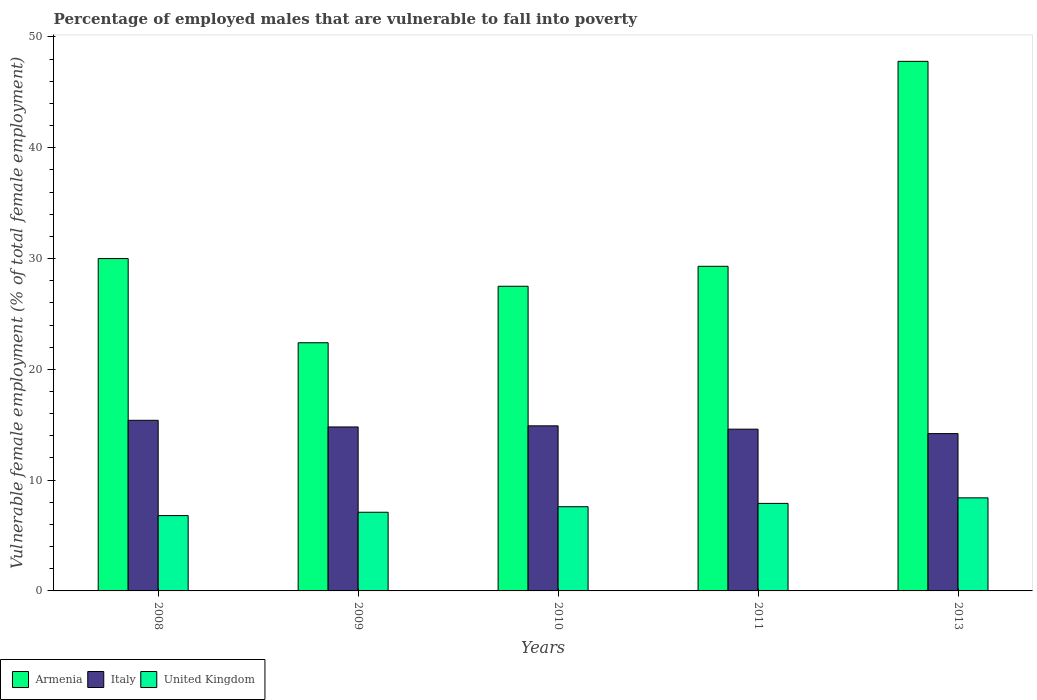How many groups of bars are there?
Your answer should be very brief. 5. Are the number of bars on each tick of the X-axis equal?
Your response must be concise. Yes. What is the percentage of employed males who are vulnerable to fall into poverty in United Kingdom in 2010?
Offer a very short reply. 7.6. Across all years, what is the maximum percentage of employed males who are vulnerable to fall into poverty in United Kingdom?
Your answer should be very brief. 8.4. Across all years, what is the minimum percentage of employed males who are vulnerable to fall into poverty in Armenia?
Offer a very short reply. 22.4. In which year was the percentage of employed males who are vulnerable to fall into poverty in Armenia minimum?
Your response must be concise. 2009. What is the total percentage of employed males who are vulnerable to fall into poverty in Armenia in the graph?
Provide a short and direct response. 157. What is the difference between the percentage of employed males who are vulnerable to fall into poverty in United Kingdom in 2010 and that in 2013?
Your answer should be very brief. -0.8. What is the difference between the percentage of employed males who are vulnerable to fall into poverty in Armenia in 2011 and the percentage of employed males who are vulnerable to fall into poverty in United Kingdom in 2013?
Your response must be concise. 20.9. What is the average percentage of employed males who are vulnerable to fall into poverty in Italy per year?
Offer a very short reply. 14.78. In the year 2009, what is the difference between the percentage of employed males who are vulnerable to fall into poverty in Armenia and percentage of employed males who are vulnerable to fall into poverty in Italy?
Offer a very short reply. 7.6. What is the ratio of the percentage of employed males who are vulnerable to fall into poverty in Italy in 2008 to that in 2011?
Give a very brief answer. 1.05. Is the percentage of employed males who are vulnerable to fall into poverty in Armenia in 2008 less than that in 2011?
Your response must be concise. No. Is the difference between the percentage of employed males who are vulnerable to fall into poverty in Armenia in 2009 and 2011 greater than the difference between the percentage of employed males who are vulnerable to fall into poverty in Italy in 2009 and 2011?
Offer a terse response. No. What is the difference between the highest and the second highest percentage of employed males who are vulnerable to fall into poverty in United Kingdom?
Ensure brevity in your answer.  0.5. What is the difference between the highest and the lowest percentage of employed males who are vulnerable to fall into poverty in Italy?
Provide a succinct answer. 1.2. Is the sum of the percentage of employed males who are vulnerable to fall into poverty in Armenia in 2010 and 2011 greater than the maximum percentage of employed males who are vulnerable to fall into poverty in Italy across all years?
Your answer should be very brief. Yes. What does the 1st bar from the left in 2011 represents?
Your answer should be very brief. Armenia. What does the 1st bar from the right in 2011 represents?
Offer a very short reply. United Kingdom. Is it the case that in every year, the sum of the percentage of employed males who are vulnerable to fall into poverty in United Kingdom and percentage of employed males who are vulnerable to fall into poverty in Italy is greater than the percentage of employed males who are vulnerable to fall into poverty in Armenia?
Keep it short and to the point. No. How many years are there in the graph?
Keep it short and to the point. 5. What is the difference between two consecutive major ticks on the Y-axis?
Provide a succinct answer. 10. Are the values on the major ticks of Y-axis written in scientific E-notation?
Keep it short and to the point. No. What is the title of the graph?
Provide a succinct answer. Percentage of employed males that are vulnerable to fall into poverty. What is the label or title of the Y-axis?
Give a very brief answer. Vulnerable female employment (% of total female employment). What is the Vulnerable female employment (% of total female employment) of Italy in 2008?
Give a very brief answer. 15.4. What is the Vulnerable female employment (% of total female employment) of United Kingdom in 2008?
Your response must be concise. 6.8. What is the Vulnerable female employment (% of total female employment) in Armenia in 2009?
Your answer should be compact. 22.4. What is the Vulnerable female employment (% of total female employment) in Italy in 2009?
Provide a succinct answer. 14.8. What is the Vulnerable female employment (% of total female employment) in United Kingdom in 2009?
Provide a short and direct response. 7.1. What is the Vulnerable female employment (% of total female employment) of Italy in 2010?
Ensure brevity in your answer.  14.9. What is the Vulnerable female employment (% of total female employment) of United Kingdom in 2010?
Provide a short and direct response. 7.6. What is the Vulnerable female employment (% of total female employment) of Armenia in 2011?
Your answer should be very brief. 29.3. What is the Vulnerable female employment (% of total female employment) in Italy in 2011?
Provide a succinct answer. 14.6. What is the Vulnerable female employment (% of total female employment) in United Kingdom in 2011?
Offer a terse response. 7.9. What is the Vulnerable female employment (% of total female employment) of Armenia in 2013?
Offer a very short reply. 47.8. What is the Vulnerable female employment (% of total female employment) in Italy in 2013?
Provide a short and direct response. 14.2. What is the Vulnerable female employment (% of total female employment) of United Kingdom in 2013?
Your response must be concise. 8.4. Across all years, what is the maximum Vulnerable female employment (% of total female employment) in Armenia?
Provide a short and direct response. 47.8. Across all years, what is the maximum Vulnerable female employment (% of total female employment) of Italy?
Your response must be concise. 15.4. Across all years, what is the maximum Vulnerable female employment (% of total female employment) of United Kingdom?
Provide a short and direct response. 8.4. Across all years, what is the minimum Vulnerable female employment (% of total female employment) of Armenia?
Provide a short and direct response. 22.4. Across all years, what is the minimum Vulnerable female employment (% of total female employment) in Italy?
Provide a succinct answer. 14.2. Across all years, what is the minimum Vulnerable female employment (% of total female employment) of United Kingdom?
Keep it short and to the point. 6.8. What is the total Vulnerable female employment (% of total female employment) of Armenia in the graph?
Your answer should be compact. 157. What is the total Vulnerable female employment (% of total female employment) of Italy in the graph?
Offer a very short reply. 73.9. What is the total Vulnerable female employment (% of total female employment) in United Kingdom in the graph?
Keep it short and to the point. 37.8. What is the difference between the Vulnerable female employment (% of total female employment) of Armenia in 2008 and that in 2009?
Offer a terse response. 7.6. What is the difference between the Vulnerable female employment (% of total female employment) in United Kingdom in 2008 and that in 2009?
Your answer should be compact. -0.3. What is the difference between the Vulnerable female employment (% of total female employment) in Italy in 2008 and that in 2011?
Ensure brevity in your answer.  0.8. What is the difference between the Vulnerable female employment (% of total female employment) of United Kingdom in 2008 and that in 2011?
Your response must be concise. -1.1. What is the difference between the Vulnerable female employment (% of total female employment) of Armenia in 2008 and that in 2013?
Provide a succinct answer. -17.8. What is the difference between the Vulnerable female employment (% of total female employment) of Italy in 2008 and that in 2013?
Your answer should be compact. 1.2. What is the difference between the Vulnerable female employment (% of total female employment) in United Kingdom in 2008 and that in 2013?
Keep it short and to the point. -1.6. What is the difference between the Vulnerable female employment (% of total female employment) in Armenia in 2009 and that in 2010?
Offer a very short reply. -5.1. What is the difference between the Vulnerable female employment (% of total female employment) in Italy in 2009 and that in 2010?
Offer a terse response. -0.1. What is the difference between the Vulnerable female employment (% of total female employment) of Armenia in 2009 and that in 2011?
Provide a succinct answer. -6.9. What is the difference between the Vulnerable female employment (% of total female employment) of United Kingdom in 2009 and that in 2011?
Ensure brevity in your answer.  -0.8. What is the difference between the Vulnerable female employment (% of total female employment) of Armenia in 2009 and that in 2013?
Provide a short and direct response. -25.4. What is the difference between the Vulnerable female employment (% of total female employment) of Italy in 2009 and that in 2013?
Offer a very short reply. 0.6. What is the difference between the Vulnerable female employment (% of total female employment) in United Kingdom in 2009 and that in 2013?
Provide a short and direct response. -1.3. What is the difference between the Vulnerable female employment (% of total female employment) of United Kingdom in 2010 and that in 2011?
Give a very brief answer. -0.3. What is the difference between the Vulnerable female employment (% of total female employment) in Armenia in 2010 and that in 2013?
Give a very brief answer. -20.3. What is the difference between the Vulnerable female employment (% of total female employment) of Italy in 2010 and that in 2013?
Keep it short and to the point. 0.7. What is the difference between the Vulnerable female employment (% of total female employment) in United Kingdom in 2010 and that in 2013?
Ensure brevity in your answer.  -0.8. What is the difference between the Vulnerable female employment (% of total female employment) in Armenia in 2011 and that in 2013?
Offer a terse response. -18.5. What is the difference between the Vulnerable female employment (% of total female employment) in Italy in 2011 and that in 2013?
Keep it short and to the point. 0.4. What is the difference between the Vulnerable female employment (% of total female employment) of United Kingdom in 2011 and that in 2013?
Keep it short and to the point. -0.5. What is the difference between the Vulnerable female employment (% of total female employment) of Armenia in 2008 and the Vulnerable female employment (% of total female employment) of United Kingdom in 2009?
Keep it short and to the point. 22.9. What is the difference between the Vulnerable female employment (% of total female employment) of Italy in 2008 and the Vulnerable female employment (% of total female employment) of United Kingdom in 2009?
Provide a succinct answer. 8.3. What is the difference between the Vulnerable female employment (% of total female employment) in Armenia in 2008 and the Vulnerable female employment (% of total female employment) in United Kingdom in 2010?
Give a very brief answer. 22.4. What is the difference between the Vulnerable female employment (% of total female employment) of Italy in 2008 and the Vulnerable female employment (% of total female employment) of United Kingdom in 2010?
Keep it short and to the point. 7.8. What is the difference between the Vulnerable female employment (% of total female employment) of Armenia in 2008 and the Vulnerable female employment (% of total female employment) of Italy in 2011?
Provide a succinct answer. 15.4. What is the difference between the Vulnerable female employment (% of total female employment) in Armenia in 2008 and the Vulnerable female employment (% of total female employment) in United Kingdom in 2011?
Give a very brief answer. 22.1. What is the difference between the Vulnerable female employment (% of total female employment) in Italy in 2008 and the Vulnerable female employment (% of total female employment) in United Kingdom in 2011?
Provide a short and direct response. 7.5. What is the difference between the Vulnerable female employment (% of total female employment) of Armenia in 2008 and the Vulnerable female employment (% of total female employment) of Italy in 2013?
Offer a very short reply. 15.8. What is the difference between the Vulnerable female employment (% of total female employment) in Armenia in 2008 and the Vulnerable female employment (% of total female employment) in United Kingdom in 2013?
Provide a short and direct response. 21.6. What is the difference between the Vulnerable female employment (% of total female employment) in Italy in 2008 and the Vulnerable female employment (% of total female employment) in United Kingdom in 2013?
Offer a very short reply. 7. What is the difference between the Vulnerable female employment (% of total female employment) in Armenia in 2009 and the Vulnerable female employment (% of total female employment) in Italy in 2010?
Your answer should be very brief. 7.5. What is the difference between the Vulnerable female employment (% of total female employment) of Italy in 2009 and the Vulnerable female employment (% of total female employment) of United Kingdom in 2010?
Your answer should be compact. 7.2. What is the difference between the Vulnerable female employment (% of total female employment) in Armenia in 2009 and the Vulnerable female employment (% of total female employment) in Italy in 2011?
Make the answer very short. 7.8. What is the difference between the Vulnerable female employment (% of total female employment) in Italy in 2009 and the Vulnerable female employment (% of total female employment) in United Kingdom in 2011?
Your answer should be compact. 6.9. What is the difference between the Vulnerable female employment (% of total female employment) of Armenia in 2009 and the Vulnerable female employment (% of total female employment) of Italy in 2013?
Offer a very short reply. 8.2. What is the difference between the Vulnerable female employment (% of total female employment) in Italy in 2009 and the Vulnerable female employment (% of total female employment) in United Kingdom in 2013?
Give a very brief answer. 6.4. What is the difference between the Vulnerable female employment (% of total female employment) in Armenia in 2010 and the Vulnerable female employment (% of total female employment) in Italy in 2011?
Keep it short and to the point. 12.9. What is the difference between the Vulnerable female employment (% of total female employment) in Armenia in 2010 and the Vulnerable female employment (% of total female employment) in United Kingdom in 2011?
Provide a short and direct response. 19.6. What is the difference between the Vulnerable female employment (% of total female employment) in Italy in 2010 and the Vulnerable female employment (% of total female employment) in United Kingdom in 2013?
Your answer should be very brief. 6.5. What is the difference between the Vulnerable female employment (% of total female employment) of Armenia in 2011 and the Vulnerable female employment (% of total female employment) of Italy in 2013?
Your response must be concise. 15.1. What is the difference between the Vulnerable female employment (% of total female employment) of Armenia in 2011 and the Vulnerable female employment (% of total female employment) of United Kingdom in 2013?
Give a very brief answer. 20.9. What is the difference between the Vulnerable female employment (% of total female employment) of Italy in 2011 and the Vulnerable female employment (% of total female employment) of United Kingdom in 2013?
Keep it short and to the point. 6.2. What is the average Vulnerable female employment (% of total female employment) of Armenia per year?
Make the answer very short. 31.4. What is the average Vulnerable female employment (% of total female employment) of Italy per year?
Ensure brevity in your answer.  14.78. What is the average Vulnerable female employment (% of total female employment) in United Kingdom per year?
Offer a terse response. 7.56. In the year 2008, what is the difference between the Vulnerable female employment (% of total female employment) of Armenia and Vulnerable female employment (% of total female employment) of United Kingdom?
Give a very brief answer. 23.2. In the year 2009, what is the difference between the Vulnerable female employment (% of total female employment) in Armenia and Vulnerable female employment (% of total female employment) in Italy?
Make the answer very short. 7.6. In the year 2009, what is the difference between the Vulnerable female employment (% of total female employment) in Armenia and Vulnerable female employment (% of total female employment) in United Kingdom?
Offer a terse response. 15.3. In the year 2009, what is the difference between the Vulnerable female employment (% of total female employment) of Italy and Vulnerable female employment (% of total female employment) of United Kingdom?
Ensure brevity in your answer.  7.7. In the year 2010, what is the difference between the Vulnerable female employment (% of total female employment) of Armenia and Vulnerable female employment (% of total female employment) of United Kingdom?
Provide a succinct answer. 19.9. In the year 2011, what is the difference between the Vulnerable female employment (% of total female employment) in Armenia and Vulnerable female employment (% of total female employment) in United Kingdom?
Your response must be concise. 21.4. In the year 2011, what is the difference between the Vulnerable female employment (% of total female employment) in Italy and Vulnerable female employment (% of total female employment) in United Kingdom?
Your answer should be compact. 6.7. In the year 2013, what is the difference between the Vulnerable female employment (% of total female employment) of Armenia and Vulnerable female employment (% of total female employment) of Italy?
Your answer should be very brief. 33.6. In the year 2013, what is the difference between the Vulnerable female employment (% of total female employment) in Armenia and Vulnerable female employment (% of total female employment) in United Kingdom?
Your response must be concise. 39.4. What is the ratio of the Vulnerable female employment (% of total female employment) of Armenia in 2008 to that in 2009?
Your response must be concise. 1.34. What is the ratio of the Vulnerable female employment (% of total female employment) in Italy in 2008 to that in 2009?
Your answer should be compact. 1.04. What is the ratio of the Vulnerable female employment (% of total female employment) in United Kingdom in 2008 to that in 2009?
Offer a terse response. 0.96. What is the ratio of the Vulnerable female employment (% of total female employment) in Armenia in 2008 to that in 2010?
Provide a short and direct response. 1.09. What is the ratio of the Vulnerable female employment (% of total female employment) in Italy in 2008 to that in 2010?
Keep it short and to the point. 1.03. What is the ratio of the Vulnerable female employment (% of total female employment) of United Kingdom in 2008 to that in 2010?
Provide a succinct answer. 0.89. What is the ratio of the Vulnerable female employment (% of total female employment) of Armenia in 2008 to that in 2011?
Your answer should be compact. 1.02. What is the ratio of the Vulnerable female employment (% of total female employment) in Italy in 2008 to that in 2011?
Provide a short and direct response. 1.05. What is the ratio of the Vulnerable female employment (% of total female employment) in United Kingdom in 2008 to that in 2011?
Offer a very short reply. 0.86. What is the ratio of the Vulnerable female employment (% of total female employment) in Armenia in 2008 to that in 2013?
Give a very brief answer. 0.63. What is the ratio of the Vulnerable female employment (% of total female employment) of Italy in 2008 to that in 2013?
Make the answer very short. 1.08. What is the ratio of the Vulnerable female employment (% of total female employment) in United Kingdom in 2008 to that in 2013?
Make the answer very short. 0.81. What is the ratio of the Vulnerable female employment (% of total female employment) in Armenia in 2009 to that in 2010?
Offer a very short reply. 0.81. What is the ratio of the Vulnerable female employment (% of total female employment) in Italy in 2009 to that in 2010?
Your answer should be very brief. 0.99. What is the ratio of the Vulnerable female employment (% of total female employment) of United Kingdom in 2009 to that in 2010?
Your answer should be very brief. 0.93. What is the ratio of the Vulnerable female employment (% of total female employment) of Armenia in 2009 to that in 2011?
Your answer should be very brief. 0.76. What is the ratio of the Vulnerable female employment (% of total female employment) of Italy in 2009 to that in 2011?
Make the answer very short. 1.01. What is the ratio of the Vulnerable female employment (% of total female employment) of United Kingdom in 2009 to that in 2011?
Ensure brevity in your answer.  0.9. What is the ratio of the Vulnerable female employment (% of total female employment) of Armenia in 2009 to that in 2013?
Ensure brevity in your answer.  0.47. What is the ratio of the Vulnerable female employment (% of total female employment) in Italy in 2009 to that in 2013?
Your response must be concise. 1.04. What is the ratio of the Vulnerable female employment (% of total female employment) in United Kingdom in 2009 to that in 2013?
Provide a succinct answer. 0.85. What is the ratio of the Vulnerable female employment (% of total female employment) in Armenia in 2010 to that in 2011?
Ensure brevity in your answer.  0.94. What is the ratio of the Vulnerable female employment (% of total female employment) of Italy in 2010 to that in 2011?
Make the answer very short. 1.02. What is the ratio of the Vulnerable female employment (% of total female employment) of United Kingdom in 2010 to that in 2011?
Provide a succinct answer. 0.96. What is the ratio of the Vulnerable female employment (% of total female employment) in Armenia in 2010 to that in 2013?
Make the answer very short. 0.58. What is the ratio of the Vulnerable female employment (% of total female employment) in Italy in 2010 to that in 2013?
Your answer should be very brief. 1.05. What is the ratio of the Vulnerable female employment (% of total female employment) of United Kingdom in 2010 to that in 2013?
Make the answer very short. 0.9. What is the ratio of the Vulnerable female employment (% of total female employment) of Armenia in 2011 to that in 2013?
Your response must be concise. 0.61. What is the ratio of the Vulnerable female employment (% of total female employment) of Italy in 2011 to that in 2013?
Your answer should be very brief. 1.03. What is the ratio of the Vulnerable female employment (% of total female employment) of United Kingdom in 2011 to that in 2013?
Give a very brief answer. 0.94. What is the difference between the highest and the second highest Vulnerable female employment (% of total female employment) in Armenia?
Provide a succinct answer. 17.8. What is the difference between the highest and the second highest Vulnerable female employment (% of total female employment) of Italy?
Offer a terse response. 0.5. What is the difference between the highest and the second highest Vulnerable female employment (% of total female employment) of United Kingdom?
Make the answer very short. 0.5. What is the difference between the highest and the lowest Vulnerable female employment (% of total female employment) of Armenia?
Provide a short and direct response. 25.4. What is the difference between the highest and the lowest Vulnerable female employment (% of total female employment) in Italy?
Ensure brevity in your answer.  1.2. 